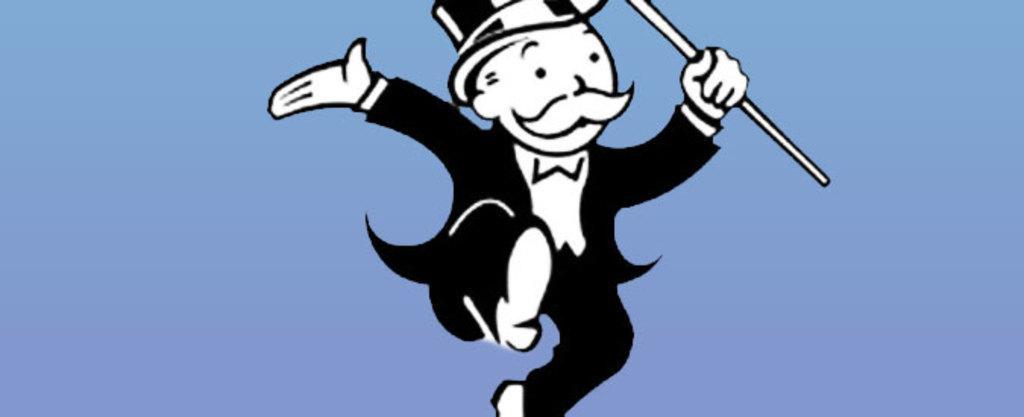Describe this image in one or two sentences. In this picture, we see the monopoly man who is holding a stick in his hand. In the background, it is blue in color. 